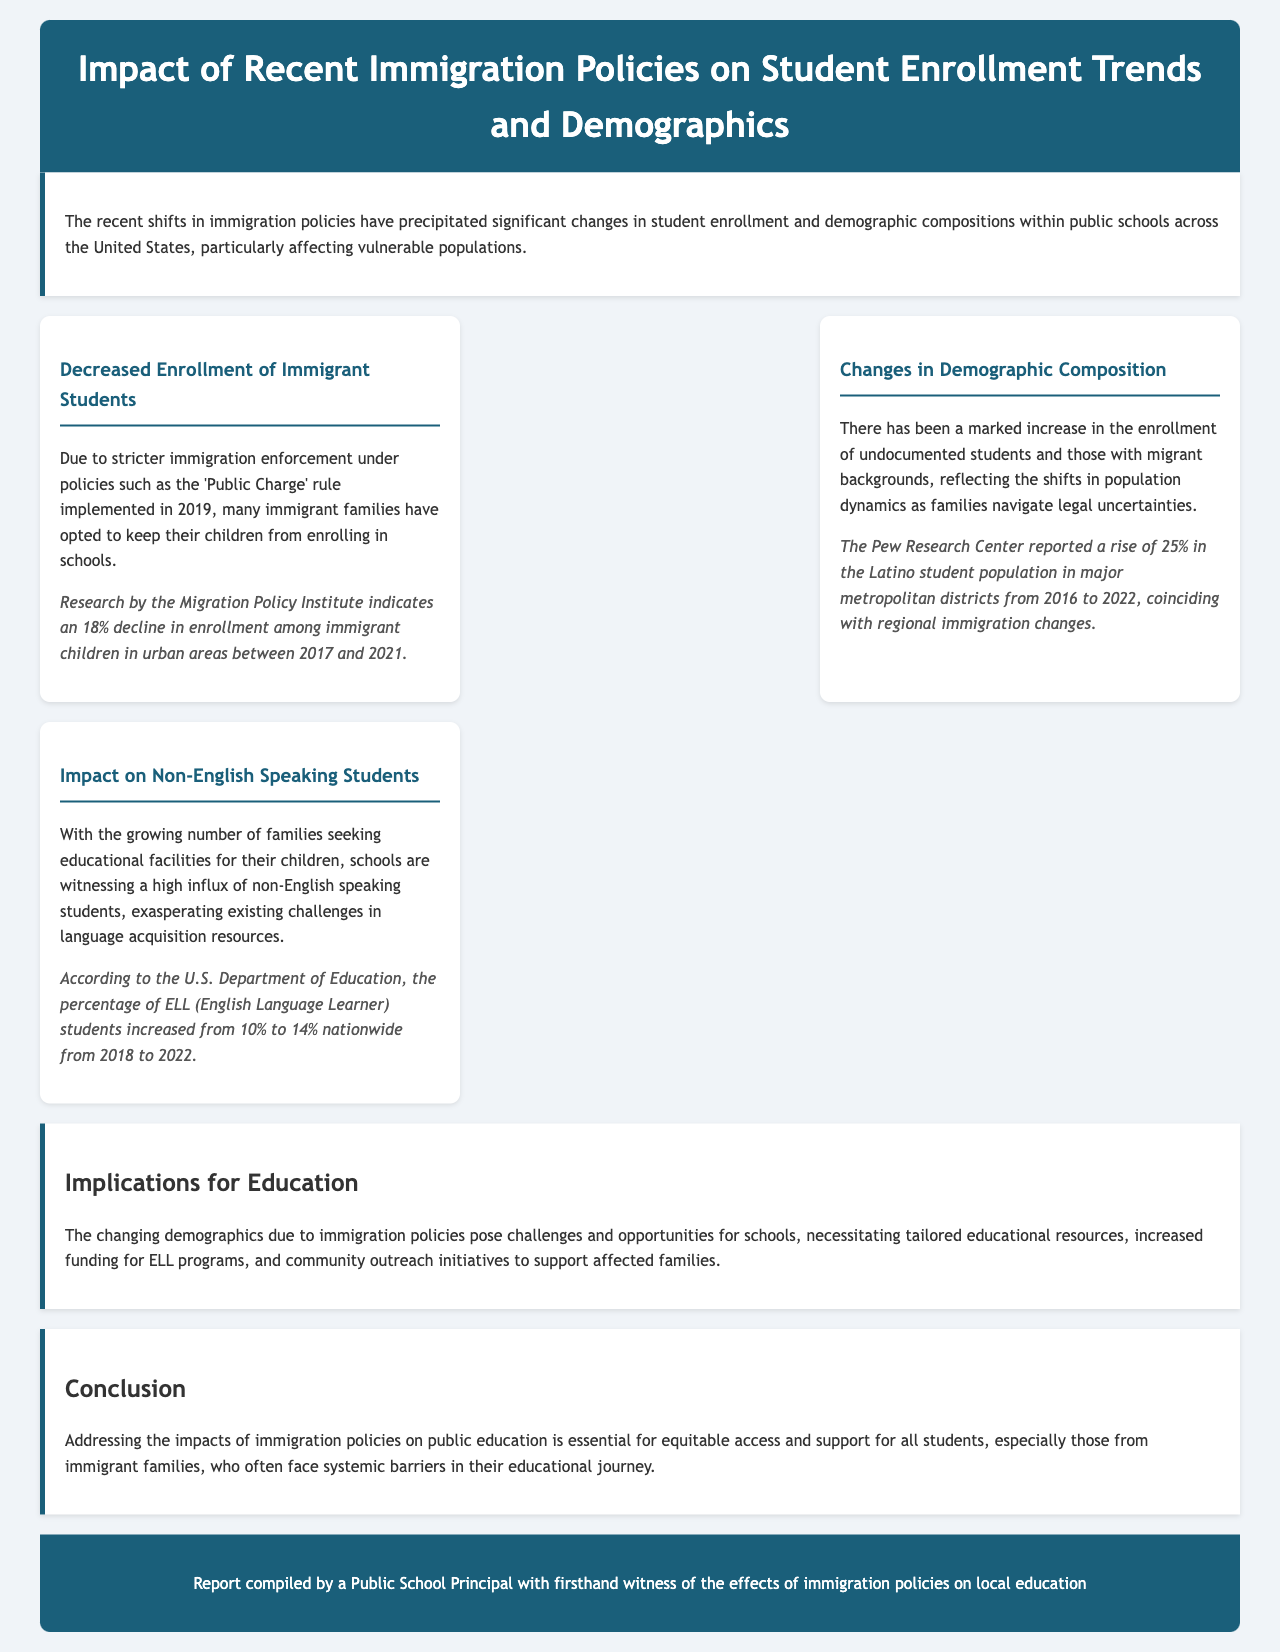What was the decline in enrollment among immigrant children? The document states that research indicated an 18% decline in enrollment among immigrant children in urban areas from 2017 to 2021.
Answer: 18% What report indicates an increase in the Latino student population? The document mentions that the Pew Research Center reported a rise of 25% in the Latino student population in major metropolitan districts from 2016 to 2022.
Answer: Pew Research Center What percentage increase of ELL students was observed from 2018 to 2022? According to the U.S. Department of Education, the percentage of ELL students increased from 10% to 14% from 2018 to 2022.
Answer: 4% What is a significant challenge mentioned for schools due to changing demographics? The document highlights the challenge of needing tailored educational resources and increased funding for ELL programs due to changing demographics.
Answer: Tailored educational resources Which immigration policy is mentioned that affected student enrollment? The document specifically cites the 'Public Charge' rule implemented in 2019 as a factor affecting student enrollment.
Answer: Public Charge What year did significant demographic changes in student enrollment start to notably affect public schools? It was stated in the document that the changes began taking notable effect around 2016, coinciding with regional immigration changes.
Answer: 2016 What does ELL stand for? The document refers to ELL as meaning English Language Learner, which increased significantly in recent years.
Answer: English Language Learner What is one implication for education mentioned in the report? The report suggests that necessitating tailored educational resources is a key implication for education stemming from immigration policy impacts.
Answer: Tailored educational resources 